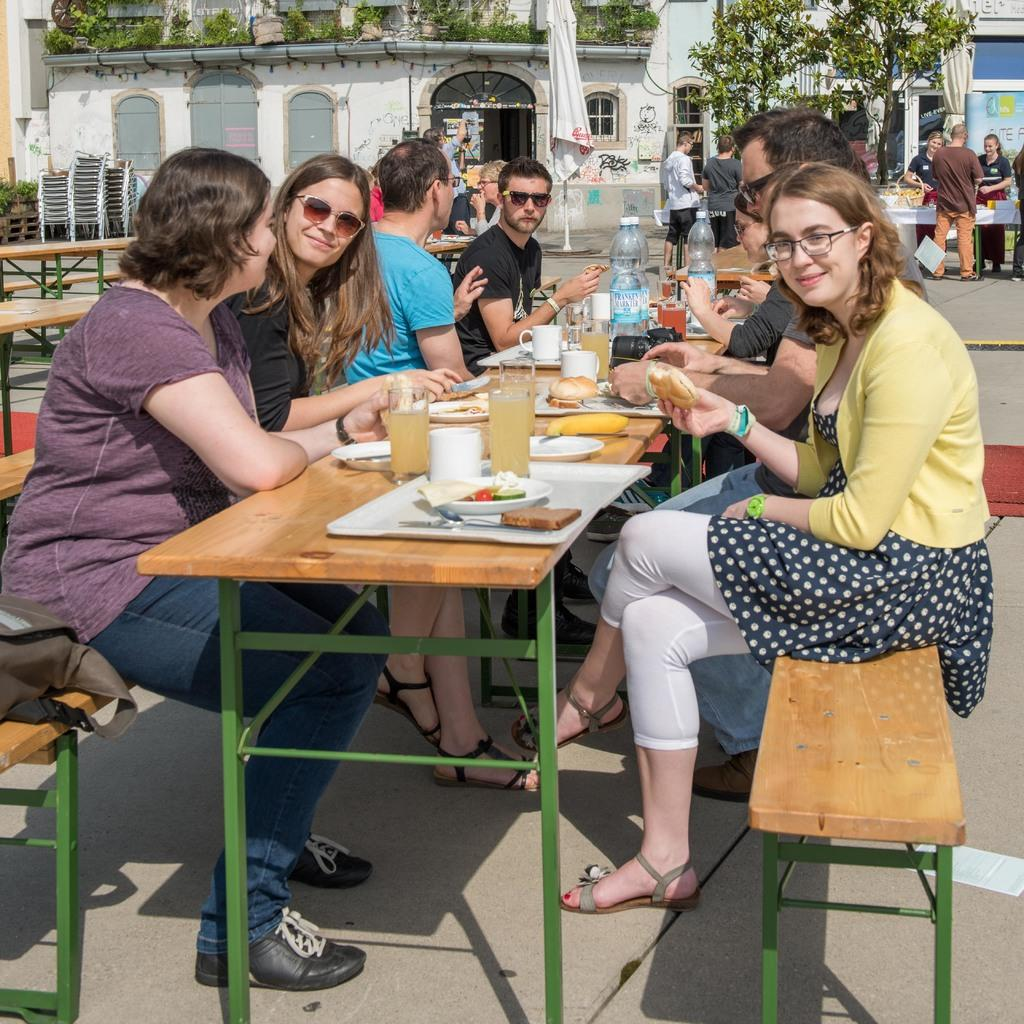How many people are in the image? There is a group of people in the image. What are the people doing in the image? The people are sitting on a bench and having food. What type of bead is being used as a decoration on the roof in the image? There is no roof or bead present in the image; it features a group of people sitting on a bench and having food. 